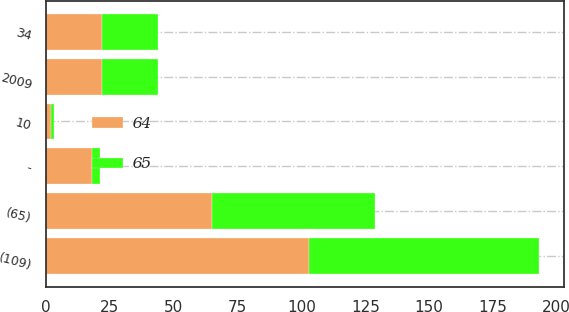Convert chart to OTSL. <chart><loc_0><loc_0><loc_500><loc_500><stacked_bar_chart><ecel><fcel>2009<fcel>(109)<fcel>34<fcel>-<fcel>10<fcel>(65)<nl><fcel>64<fcel>22<fcel>103<fcel>22<fcel>18<fcel>2<fcel>65<nl><fcel>65<fcel>22<fcel>90<fcel>22<fcel>3<fcel>1<fcel>64<nl></chart> 